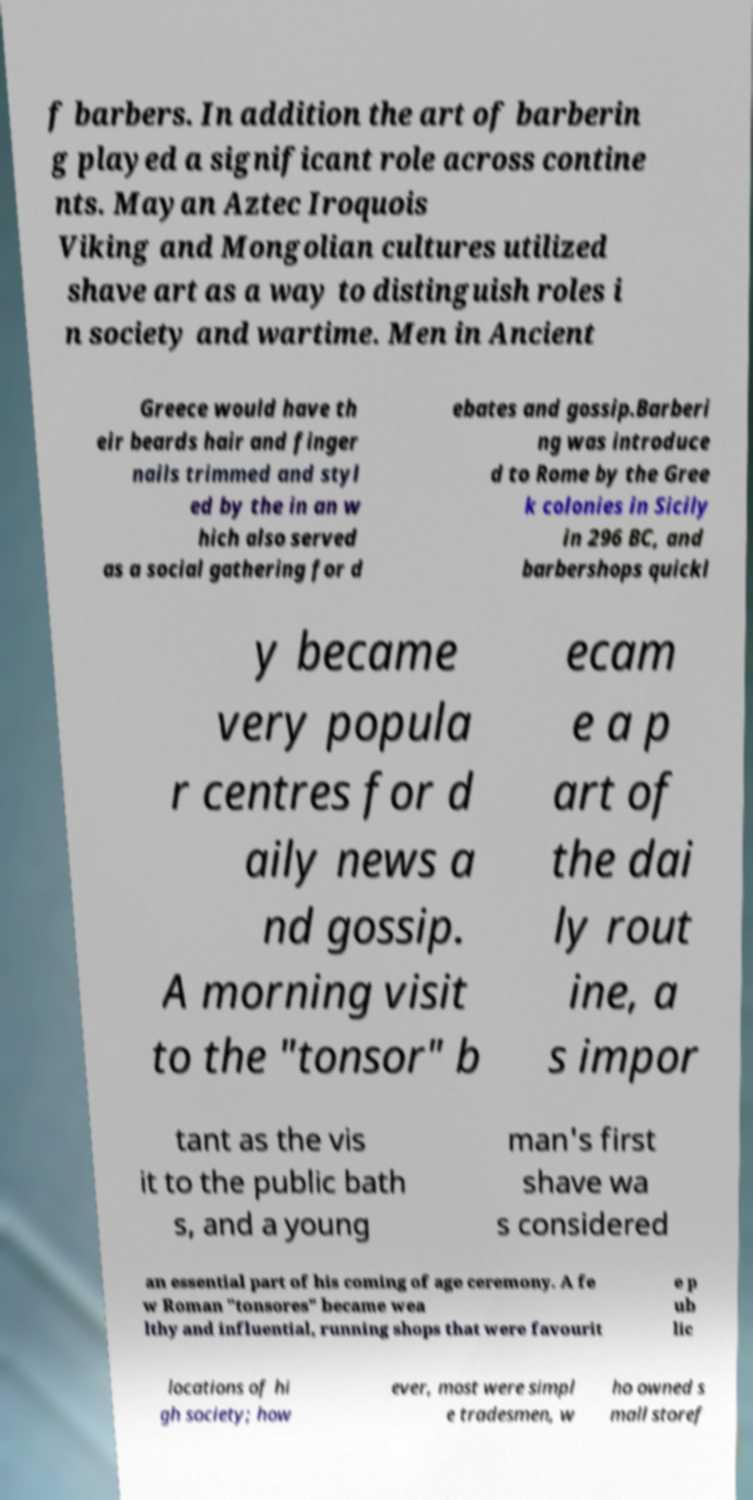Can you accurately transcribe the text from the provided image for me? f barbers. In addition the art of barberin g played a significant role across contine nts. Mayan Aztec Iroquois Viking and Mongolian cultures utilized shave art as a way to distinguish roles i n society and wartime. Men in Ancient Greece would have th eir beards hair and finger nails trimmed and styl ed by the in an w hich also served as a social gathering for d ebates and gossip.Barberi ng was introduce d to Rome by the Gree k colonies in Sicily in 296 BC, and barbershops quickl y became very popula r centres for d aily news a nd gossip. A morning visit to the "tonsor" b ecam e a p art of the dai ly rout ine, a s impor tant as the vis it to the public bath s, and a young man's first shave wa s considered an essential part of his coming of age ceremony. A fe w Roman "tonsores" became wea lthy and influential, running shops that were favourit e p ub lic locations of hi gh society; how ever, most were simpl e tradesmen, w ho owned s mall storef 